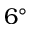Convert formula to latex. <formula><loc_0><loc_0><loc_500><loc_500>6 ^ { \circ }</formula> 